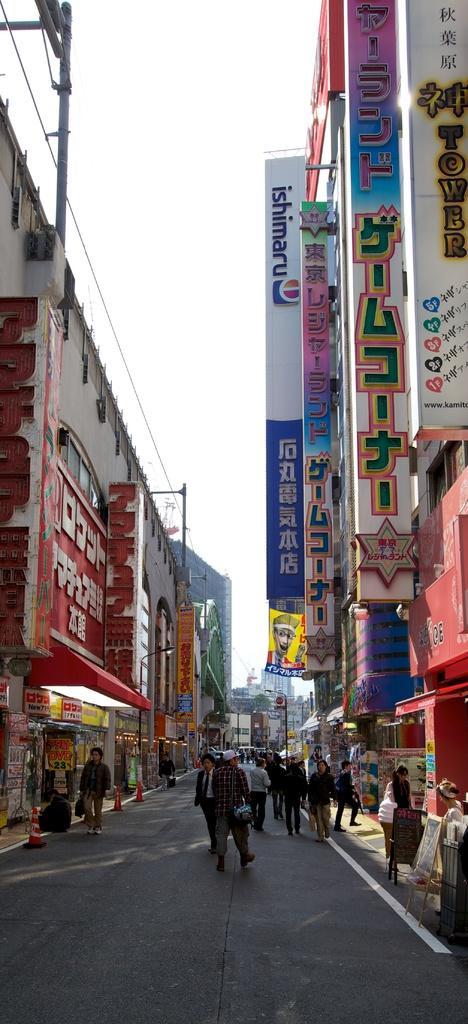Describe this image in one or two sentences. Few people are walking on the road. We can see buildings,boards and sky. 